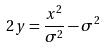Convert formula to latex. <formula><loc_0><loc_0><loc_500><loc_500>2 y = \frac { x ^ { 2 } } { \sigma ^ { 2 } } - \sigma ^ { 2 }</formula> 